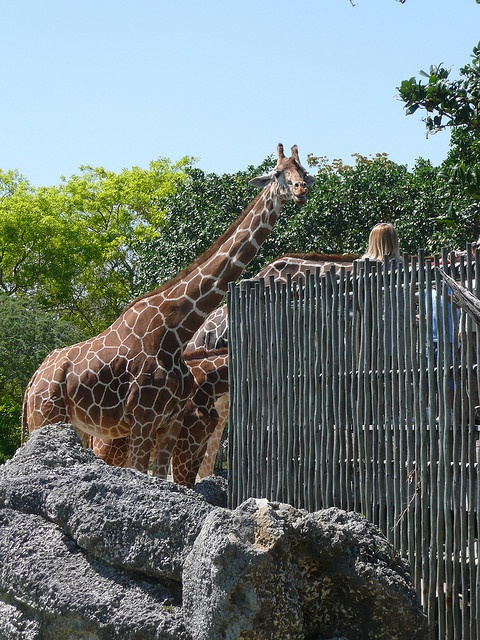Describe the objects in this image and their specific colors. I can see giraffe in lightblue, black, gray, and maroon tones, giraffe in lightblue, black, gray, and maroon tones, and people in lightblue, black, gray, and tan tones in this image. 